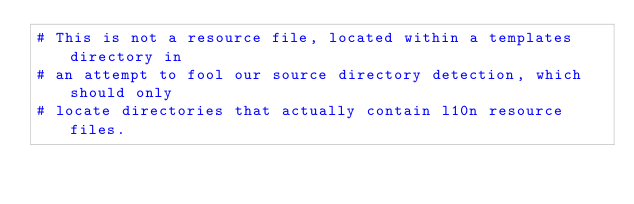Convert code to text. <code><loc_0><loc_0><loc_500><loc_500><_Python_># This is not a resource file, located within a templates directory in
# an attempt to fool our source directory detection, which should only
# locate directories that actually contain l10n resource files.
</code> 